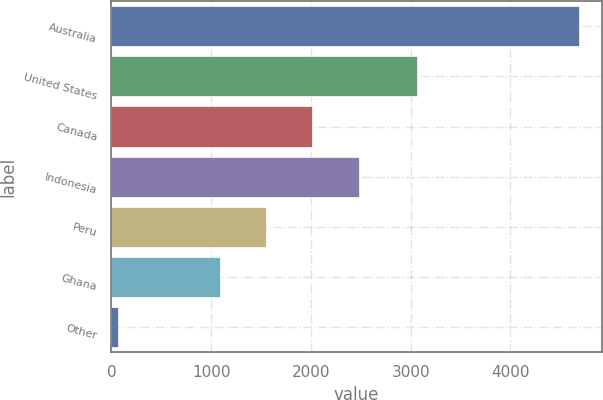Convert chart to OTSL. <chart><loc_0><loc_0><loc_500><loc_500><bar_chart><fcel>Australia<fcel>United States<fcel>Canada<fcel>Indonesia<fcel>Peru<fcel>Ghana<fcel>Other<nl><fcel>4683<fcel>3059<fcel>2015.6<fcel>2476.9<fcel>1554.3<fcel>1093<fcel>70<nl></chart> 